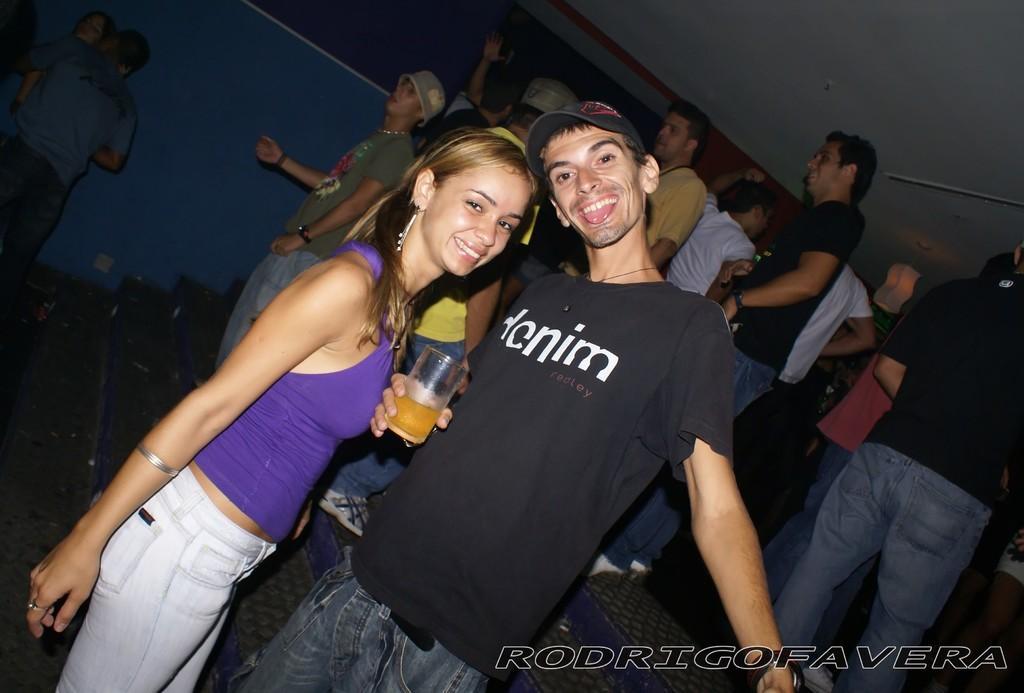Describe this image in one or two sentences. In the foreground of this image, there is a couple standing and having smile on their faces and the man is holding a glass in his hand. In the background, there are persons standing, stairs, wall, ceiling and the light. 